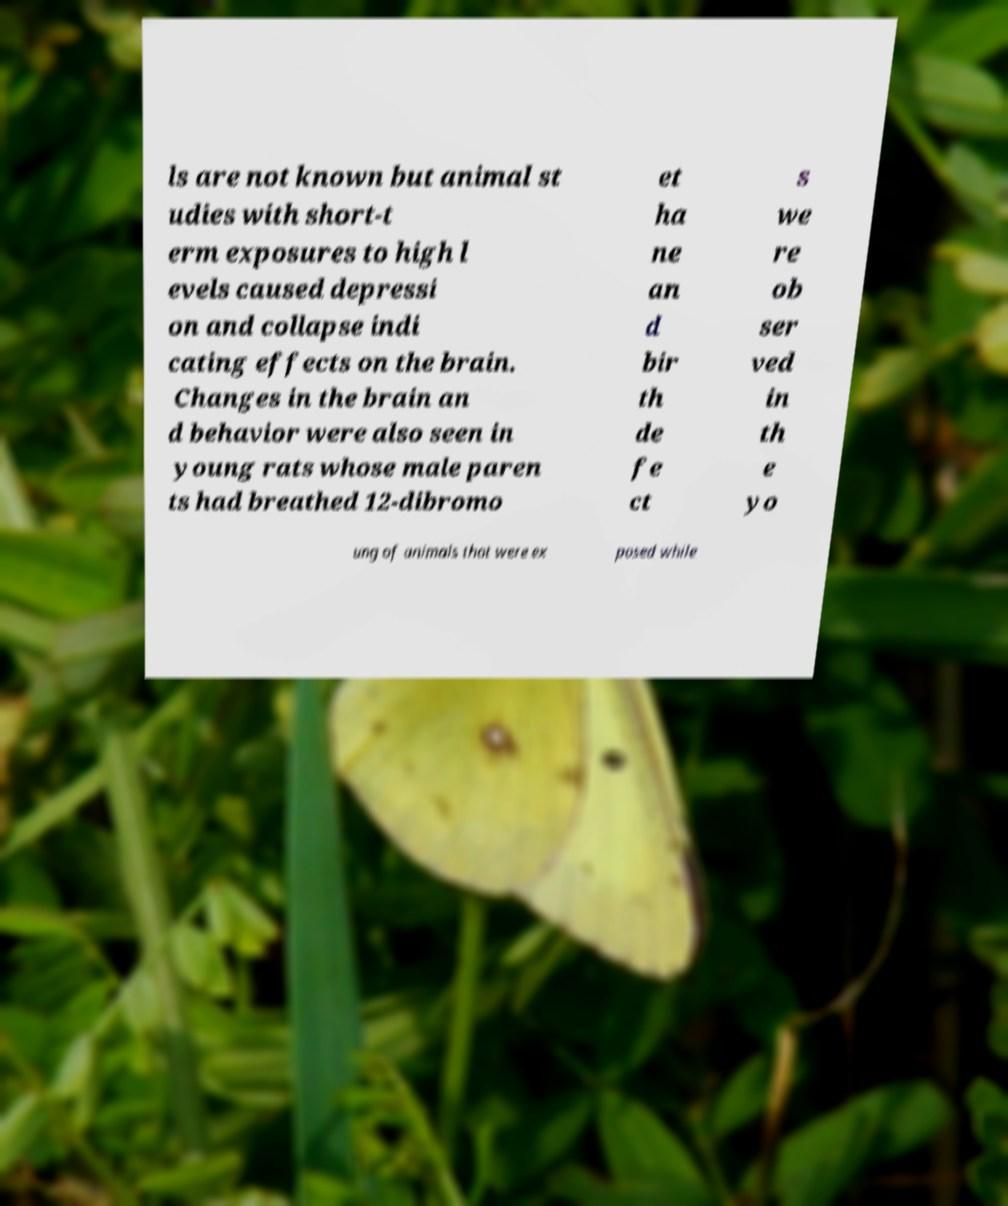Could you extract and type out the text from this image? ls are not known but animal st udies with short-t erm exposures to high l evels caused depressi on and collapse indi cating effects on the brain. Changes in the brain an d behavior were also seen in young rats whose male paren ts had breathed 12-dibromo et ha ne an d bir th de fe ct s we re ob ser ved in th e yo ung of animals that were ex posed while 